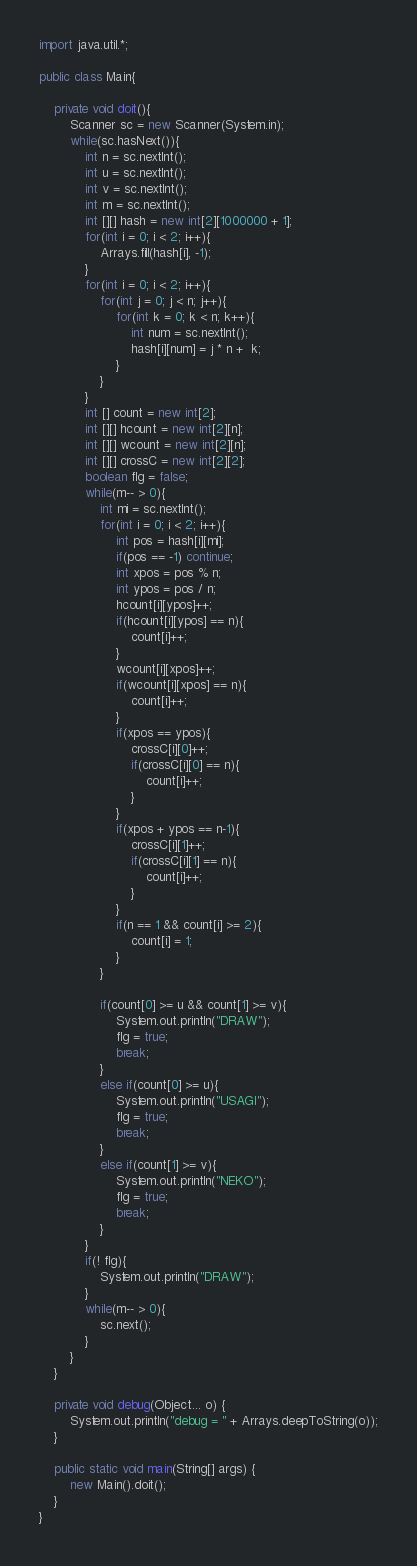Convert code to text. <code><loc_0><loc_0><loc_500><loc_500><_Java_>import java.util.*;

public class Main{
	
	private void doit(){
		Scanner sc = new Scanner(System.in);
		while(sc.hasNext()){
			int n = sc.nextInt();
			int u = sc.nextInt();
			int v = sc.nextInt();
			int m = sc.nextInt();
			int [][] hash = new int[2][1000000 + 1];
			for(int i = 0; i < 2; i++){
				Arrays.fill(hash[i], -1);
			}
			for(int i = 0; i < 2; i++){
				for(int j = 0; j < n; j++){
					for(int k = 0; k < n; k++){
						int num = sc.nextInt();
						hash[i][num] = j * n +  k;
					}
				}
			}
			int [] count = new int[2];
			int [][] hcount = new int[2][n];
			int [][] wcount = new int[2][n];
			int [][] crossC = new int[2][2];
			boolean flg = false;
			while(m-- > 0){
				int mi = sc.nextInt();
				for(int i = 0; i < 2; i++){
					int pos = hash[i][mi];
					if(pos == -1) continue;
					int xpos = pos % n;
					int ypos = pos / n;
					hcount[i][ypos]++;
					if(hcount[i][ypos] == n){
						count[i]++;
					}
					wcount[i][xpos]++;
					if(wcount[i][xpos] == n){
						count[i]++;
					}
					if(xpos == ypos){
						crossC[i][0]++;
						if(crossC[i][0] == n){
							count[i]++;
						}
					}
					if(xpos + ypos == n-1){
						crossC[i][1]++;
						if(crossC[i][1] == n){
							count[i]++;
						}
					}
					if(n == 1 && count[i] >= 2){
						count[i] = 1;
					}
				}
				
				if(count[0] >= u && count[1] >= v){
					System.out.println("DRAW");
					flg = true;
					break;
				}
				else if(count[0] >= u){
					System.out.println("USAGI");
					flg = true;
					break;
				}
				else if(count[1] >= v){
					System.out.println("NEKO");
					flg = true;
					break;
				}
			}
			if(! flg){
				System.out.println("DRAW");
			}
			while(m-- > 0){
				sc.next();
			}
		}
	}

	private void debug(Object... o) {
		System.out.println("debug = " + Arrays.deepToString(o));
	}

	public static void main(String[] args) {
		new Main().doit();
	}
}</code> 